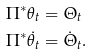Convert formula to latex. <formula><loc_0><loc_0><loc_500><loc_500>\Pi ^ { * } \theta _ { t } & = \Theta _ { t } \\ \Pi ^ { * } \dot { \theta } _ { t } & = \dot { \Theta } _ { t } .</formula> 